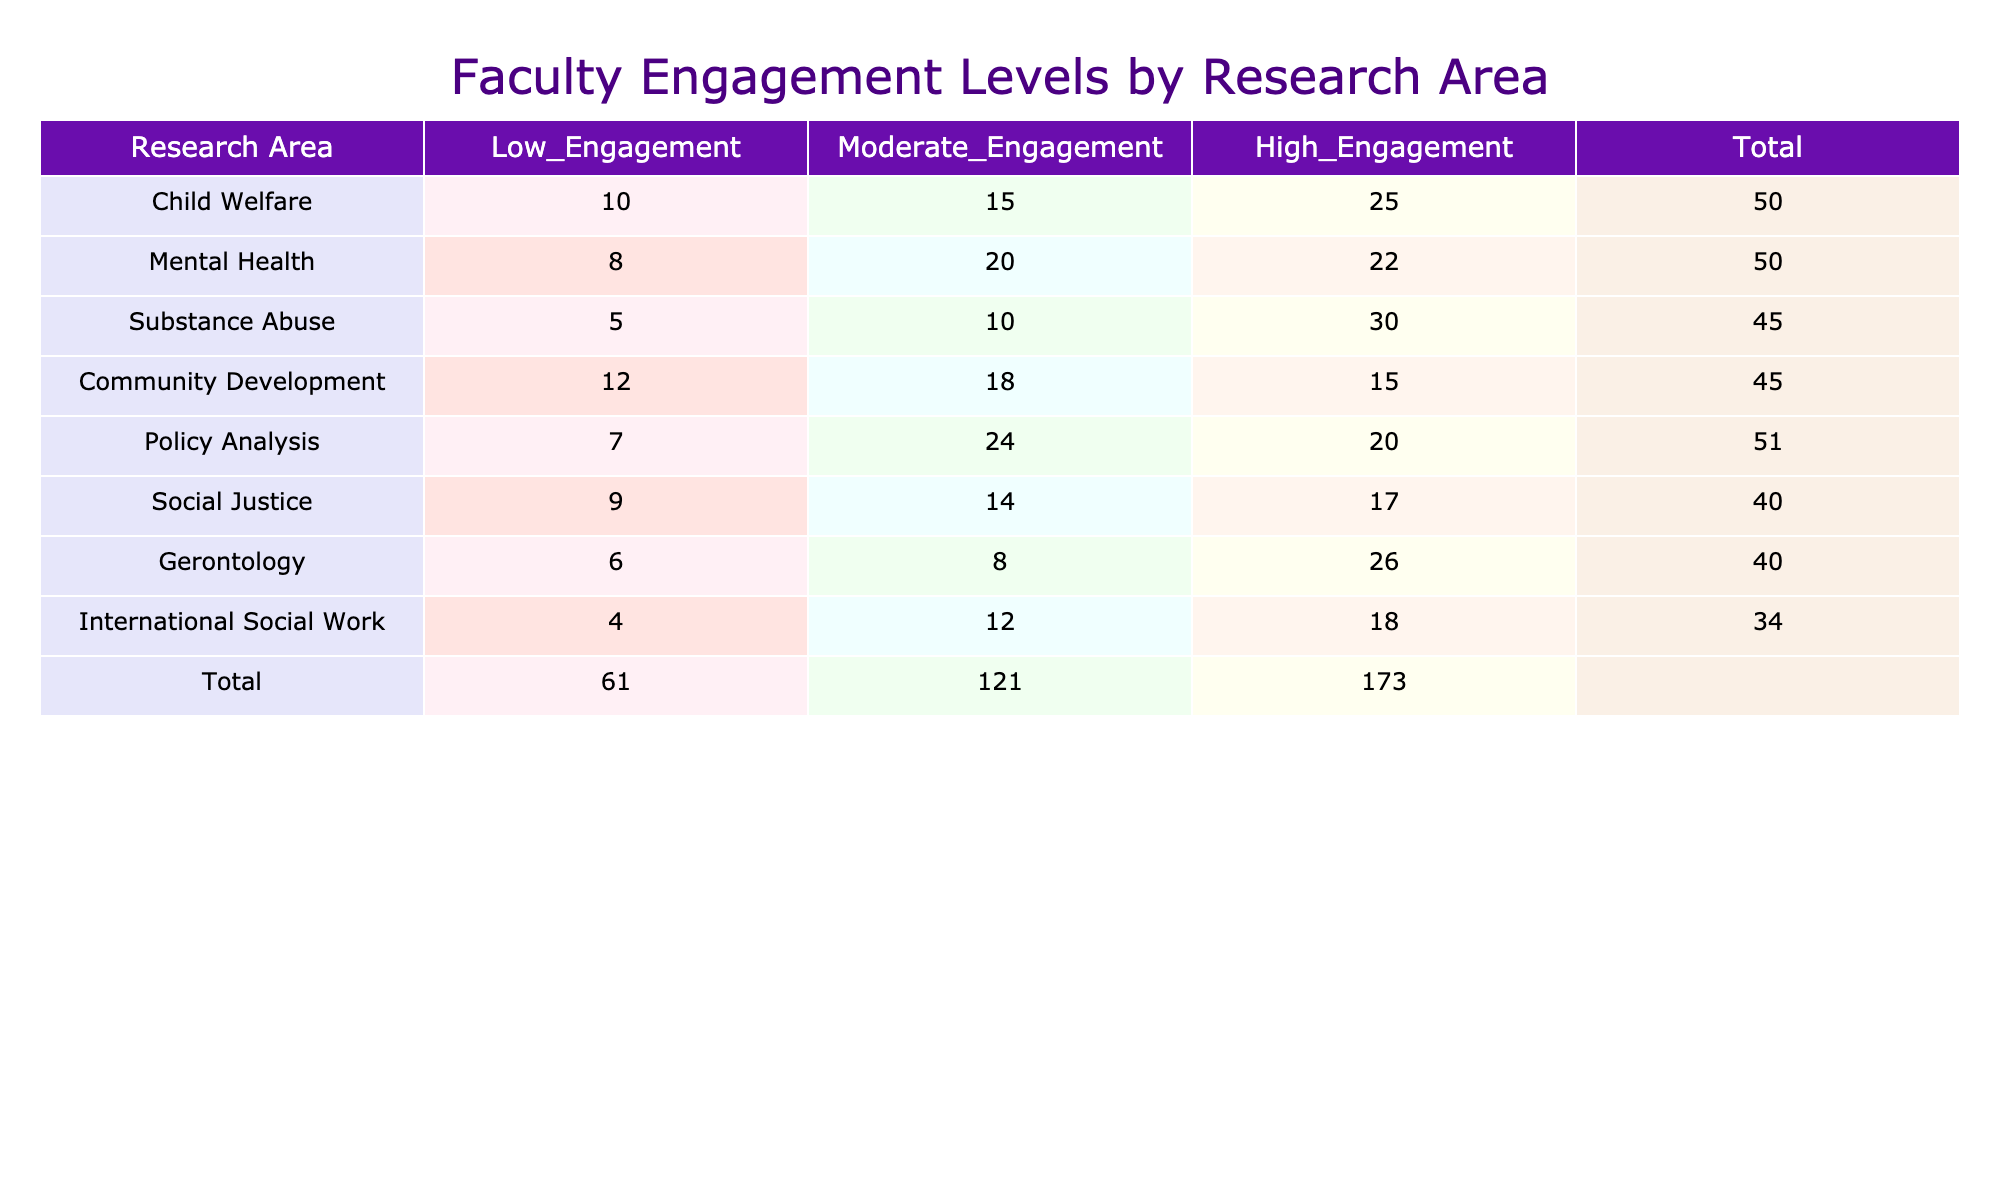What is the total number of faculty members engaged in the Substance Abuse research area at all levels? To find the total number of faculty members engaged in the Substance Abuse research area, add the values from all engagement levels: 5 (Low) + 10 (Moderate) + 30 (High) = 45.
Answer: 45 Which research area has the highest number of faculty at a High Engagement level? Looking at the High Engagement column, the highest value is 30 in the Substance Abuse research area.
Answer: Substance Abuse Is the total engagement in Community Development greater than in Gerontology? First, calculate the total for Community Development: 12 (Low) + 18 (Moderate) + 15 (High) = 45. Then, calculate for Gerontology: 6 (Low) + 8 (Moderate) + 26 (High) = 40. Since 45 is greater than 40, the answer is yes.
Answer: Yes What is the average number of faculty engaged at a Moderate level across all research areas? There are 8 research areas, and the total number at Moderate engagement is 15 + 20 + 10 + 18 + 24 + 14 + 8 + 12 = 131. The average is then 131 / 8 = 16.375.
Answer: 16.375 How many more faculty members are engaged at the High level in Child Welfare compared to Mental Health? The number of High Engagement faculty in Child Welfare is 25, and in Mental Health, it is 22. Subtracting these gives: 25 - 22 = 3.
Answer: 3 Does the total number of faculty engaged in Policy Analysis equal the total for Social Justice? For Policy Analysis, the total is 7 (Low) + 24 (Moderate) + 20 (High) = 51. For Social Justice, it is 9 (Low) + 14 (Moderate) + 17 (High) = 40. Since 51 does not equal 40, the answer is no.
Answer: No What is the overall total number of faculty members across all research areas? Add all the values from each engagement level in the table: (10 + 15 + 25) + (8 + 20 + 22) + (5 + 10 + 30) + (12 + 18 + 15) + (7 + 24 + 20) + (9 + 14 + 17) + (6 + 8 + 26) + (4 + 12 + 18) =  90 + 50 + 45 + 45 + 51 + 40 + 40 + 34 = 395.
Answer: 395 Which research area has the lowest total engagement across all levels? Calculate the total engagement for each area: Child Welfare (50), Mental Health (50), Substance Abuse (45), Community Development (45), Policy Analysis (51), Social Justice (40), Gerontology (40), International Social Work (34). The lowest is International Social Work with 34.
Answer: International Social Work 